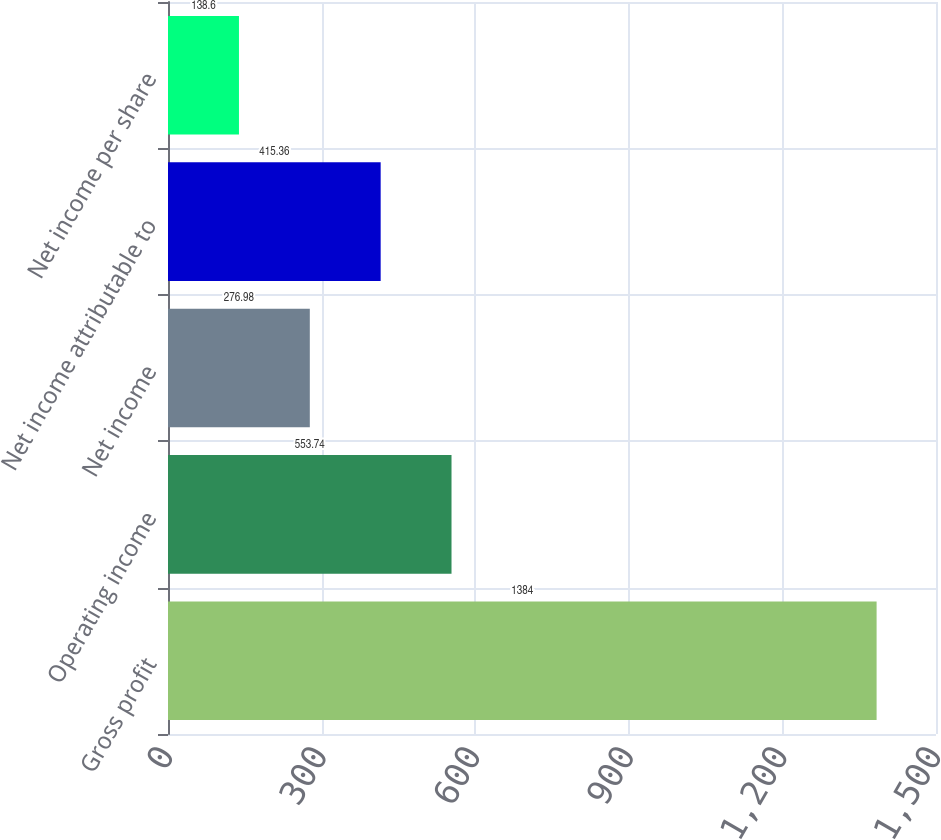<chart> <loc_0><loc_0><loc_500><loc_500><bar_chart><fcel>Gross profit<fcel>Operating income<fcel>Net income<fcel>Net income attributable to<fcel>Net income per share<nl><fcel>1384<fcel>553.74<fcel>276.98<fcel>415.36<fcel>138.6<nl></chart> 